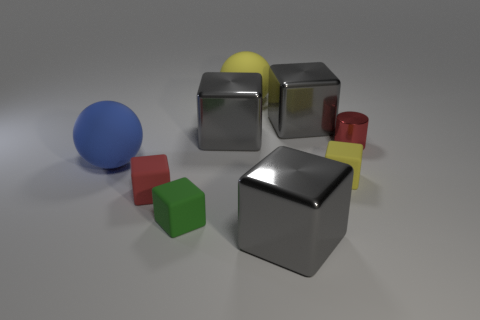Which objects in the image are capable of casting the sharpest shadows? The objects with the most defined edges, such as the cubes and the cylinder, are capable of casting the sharpest shadows. The sharp edges and flat surfaces create clear, distinct lines of shadows in contrast to the more diffused shadows that would be cast by the spheres. 